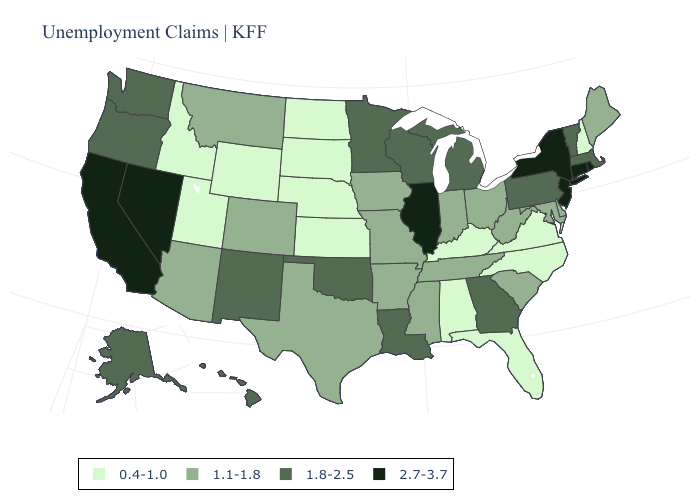Name the states that have a value in the range 0.4-1.0?
Be succinct. Alabama, Florida, Idaho, Kansas, Kentucky, Nebraska, New Hampshire, North Carolina, North Dakota, South Dakota, Utah, Virginia, Wyoming. Name the states that have a value in the range 1.8-2.5?
Short answer required. Alaska, Georgia, Hawaii, Louisiana, Massachusetts, Michigan, Minnesota, New Mexico, Oklahoma, Oregon, Pennsylvania, Vermont, Washington, Wisconsin. Does Alabama have a lower value than South Carolina?
Short answer required. Yes. What is the lowest value in the USA?
Be succinct. 0.4-1.0. What is the value of Wyoming?
Write a very short answer. 0.4-1.0. What is the lowest value in states that border New Hampshire?
Short answer required. 1.1-1.8. What is the value of Arkansas?
Write a very short answer. 1.1-1.8. What is the lowest value in the South?
Give a very brief answer. 0.4-1.0. Among the states that border Utah , which have the highest value?
Give a very brief answer. Nevada. What is the highest value in the USA?
Keep it brief. 2.7-3.7. Does Kansas have a lower value than New Hampshire?
Keep it brief. No. Which states hav the highest value in the Northeast?
Give a very brief answer. Connecticut, New Jersey, New York, Rhode Island. Does the first symbol in the legend represent the smallest category?
Concise answer only. Yes. Name the states that have a value in the range 1.1-1.8?
Concise answer only. Arizona, Arkansas, Colorado, Delaware, Indiana, Iowa, Maine, Maryland, Mississippi, Missouri, Montana, Ohio, South Carolina, Tennessee, Texas, West Virginia. Does Oklahoma have the highest value in the South?
Short answer required. Yes. 